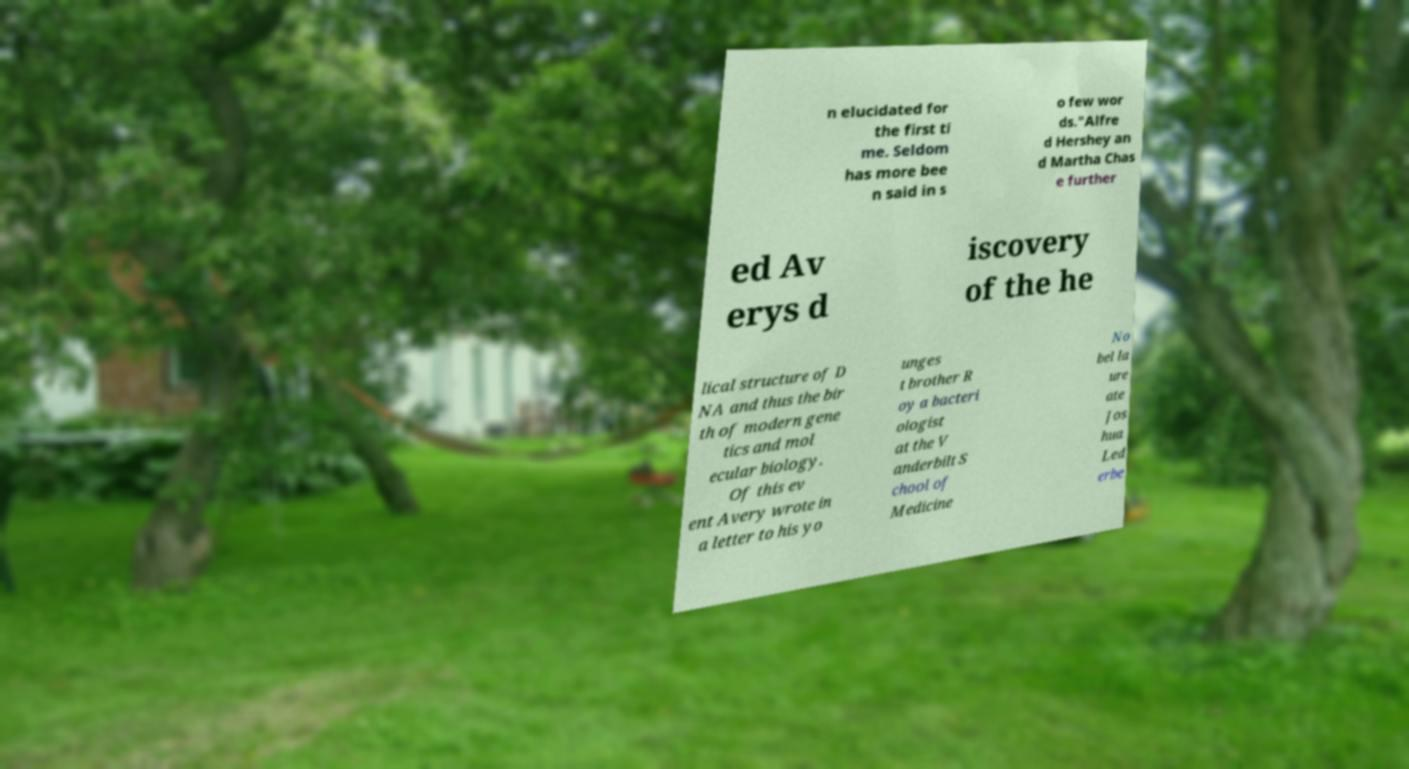Can you read and provide the text displayed in the image?This photo seems to have some interesting text. Can you extract and type it out for me? n elucidated for the first ti me. Seldom has more bee n said in s o few wor ds."Alfre d Hershey an d Martha Chas e further ed Av erys d iscovery of the he lical structure of D NA and thus the bir th of modern gene tics and mol ecular biology. Of this ev ent Avery wrote in a letter to his yo unges t brother R oy a bacteri ologist at the V anderbilt S chool of Medicine No bel la ure ate Jos hua Led erbe 